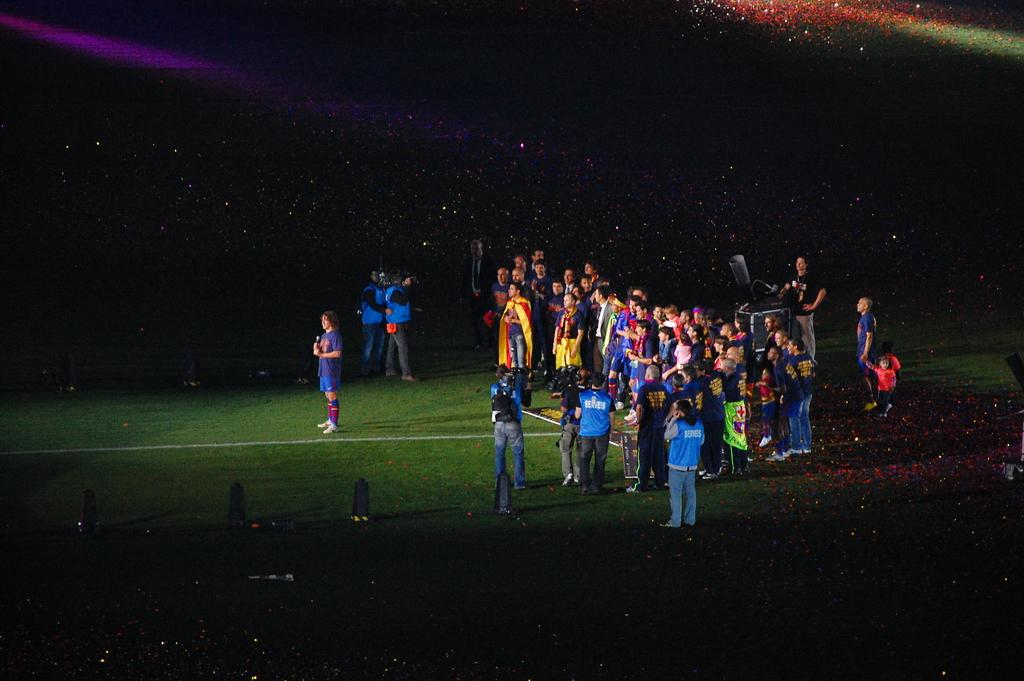How many people are in the image? There is a group of people in the image. What are the people in the image doing? The people are standing on the ground. Can you describe the person holding an object in their hands? There is a person holding a microphone in their hands. What is the color of the background in the image? The background of the image is dark. Can you tell me how many goats are present in the image? There are no goats present in the image; it features a group of people standing on the ground. What type of rhythm is being played by the people in the image? There is no indication of any music or rhythm in the image; it only shows a group of people standing on the ground. 